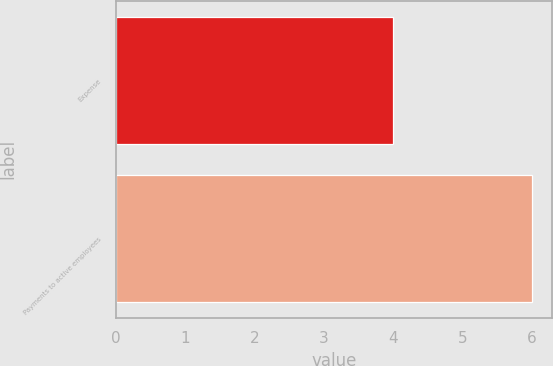Convert chart to OTSL. <chart><loc_0><loc_0><loc_500><loc_500><bar_chart><fcel>Expense<fcel>Payments to active employees<nl><fcel>4<fcel>6<nl></chart> 